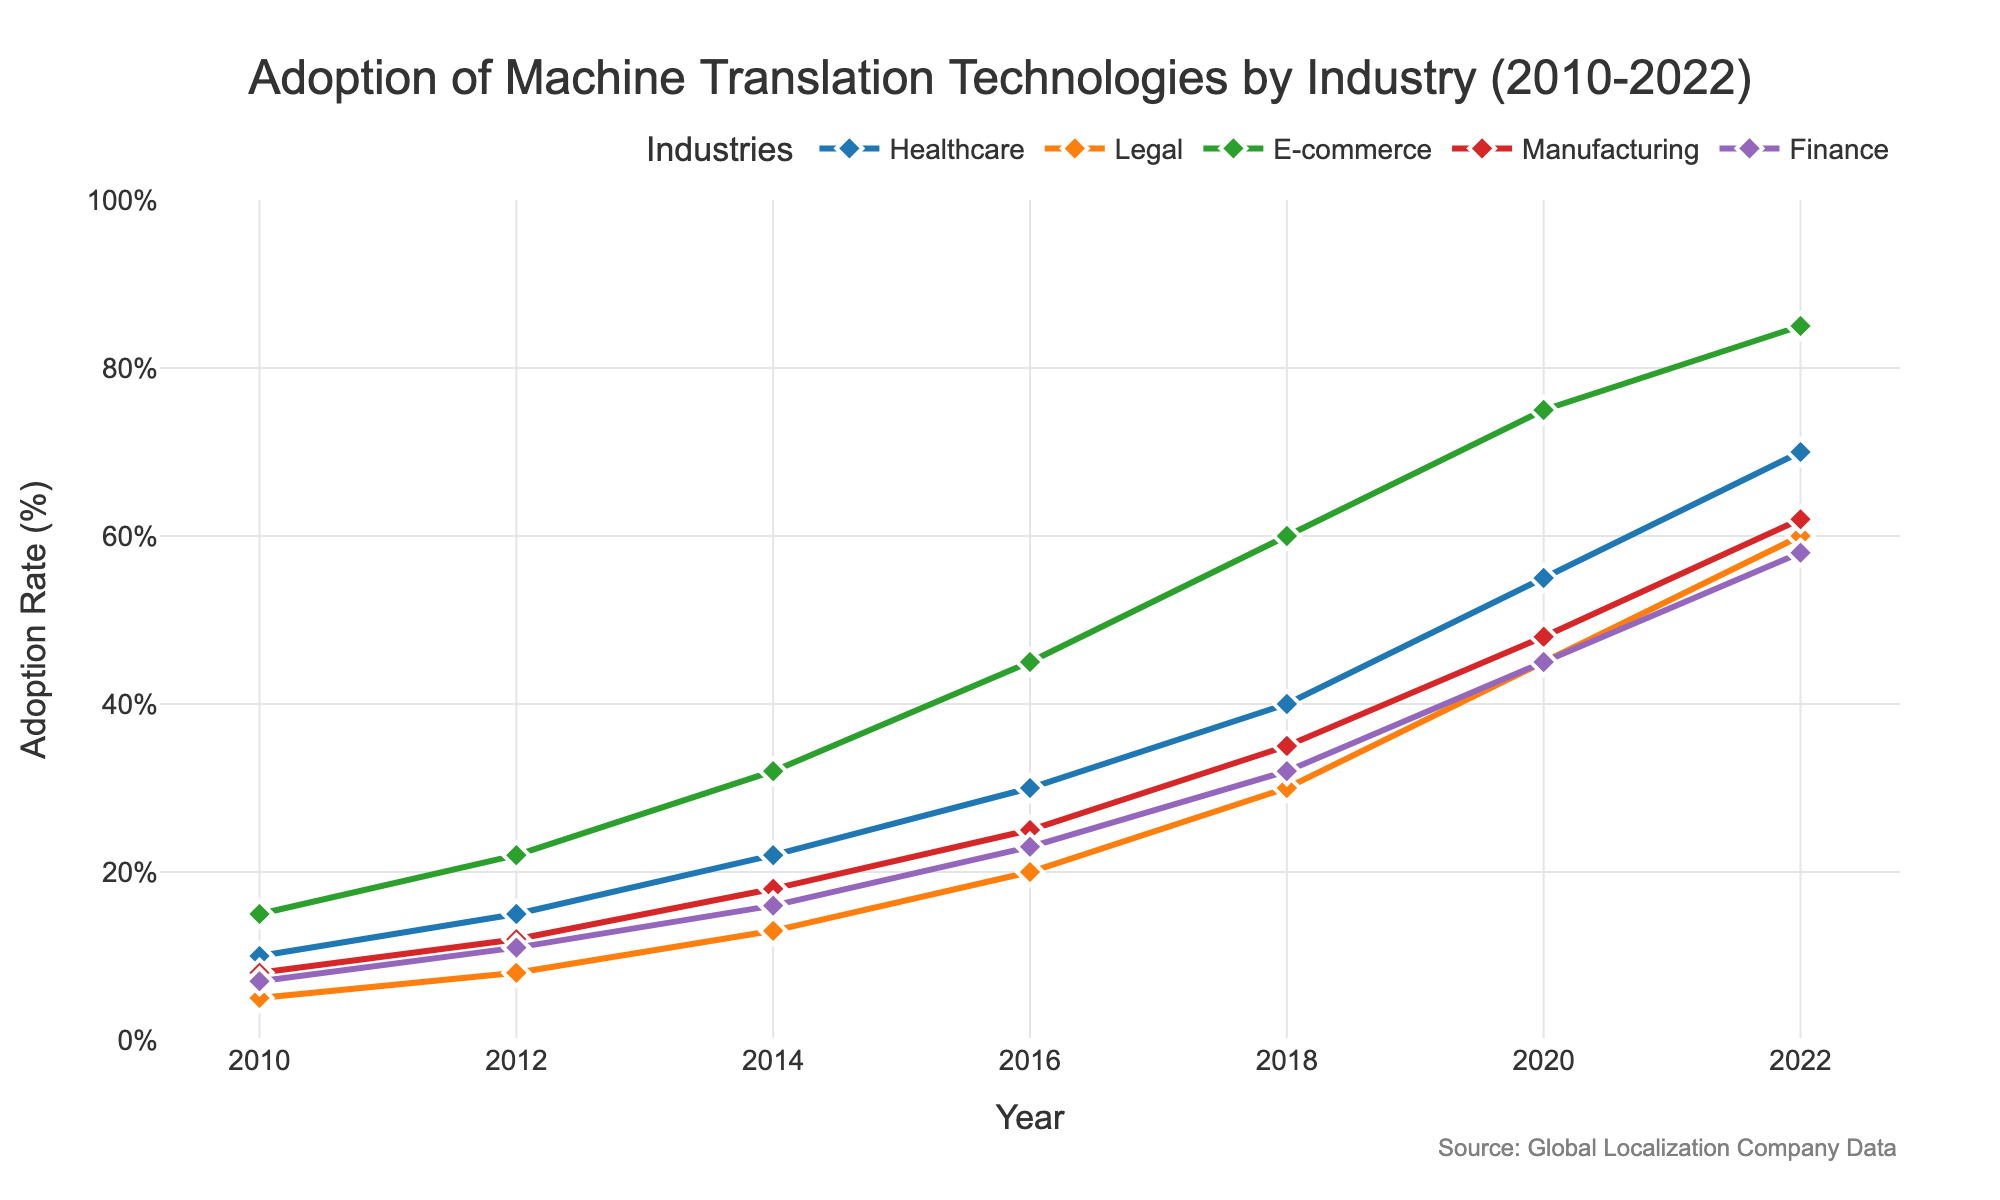What industry saw the highest adoption rate in 2022? The line chart shows different adoption rates per industry, and the value for each industry in 2022. Among all industries, E-commerce had the highest rate at 85%.
Answer: E-commerce Which industry experienced the largest increase in adoption rates between 2010 and 2022? By calculating the difference between the starting and ending values for each industry, Healthcare increased by 60%, Legal by 55%, E-commerce by 70%, Manufacturing by 54%, and Finance by 51%. Therefore, E-commerce had the largest increase.
Answer: E-commerce What is the difference in adoption rates between Healthcare and Legal industries in 2018? From the plot, Healthcare has an adoption rate of 40% while Legal has 30% in 2018. The difference is 40% - 30% = 10%.
Answer: 10% Which industry had the lowest adoption rate in 2014? By checking the values on the plot for 2014, Legal had the lowest adoption rate with 13%.
Answer: Legal Calculate the average adoption rate in 2016 across all industries. Summing the adoption rates for all industries in 2016: Healthcare (30) + Legal (20) + E-commerce (45) + Manufacturing (25) + Finance (23) equals 143. The average rate is 143 / 5 = 28.6%.
Answer: 28.6% By how much did the adoption rate in the Finance industry increase from 2010 to 2020? The adoption rate for Finance in 2010 was 7% and in 2020 it was 45%. The increase is therefore 45% - 7% = 38%.
Answer: 38% What is the combined adoption rate of Manufacturing and Finance industries in 2022? The adoption rates in 2022 are 62% for Manufacturing and 58% for Finance, so the combined rate is 62% + 58% = 120%.
Answer: 120% Which industry showed a consistent increase in adoption rate every year? Looking at the lines for each industry, all industries show a consistent increase each year.
Answer: All How does the increase in adoption rates from 2016 to 2020 compare between E-commerce and Manufacturing? E-commerce increases from 45% in 2016 to 75% in 2020, an increase of 30%. Manufacturing increases from 25% in 2016 to 48% in 2020, an increase of 23%.
Answer: E-commerce had a higher increase by 7% What is the visual difference between the E-commerce and Finance industries' lines? The lines for E-commerce and Finance differ in height, with E-commerce consistently higher, and also in color; E-commerce is represented by an orange line, and Finance by a purple line.
Answer: E-commerce line is higher and orange; Finance line is lower and purple 